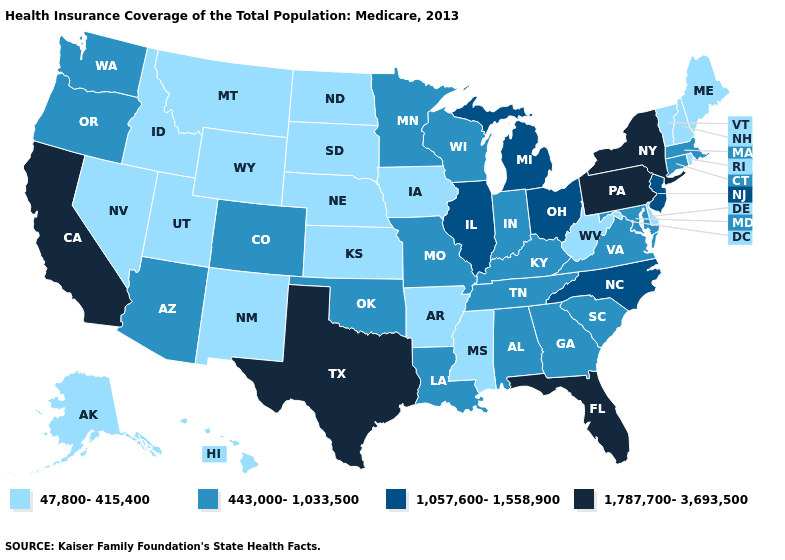Name the states that have a value in the range 443,000-1,033,500?
Answer briefly. Alabama, Arizona, Colorado, Connecticut, Georgia, Indiana, Kentucky, Louisiana, Maryland, Massachusetts, Minnesota, Missouri, Oklahoma, Oregon, South Carolina, Tennessee, Virginia, Washington, Wisconsin. Name the states that have a value in the range 1,057,600-1,558,900?
Concise answer only. Illinois, Michigan, New Jersey, North Carolina, Ohio. Name the states that have a value in the range 1,057,600-1,558,900?
Quick response, please. Illinois, Michigan, New Jersey, North Carolina, Ohio. Is the legend a continuous bar?
Short answer required. No. Among the states that border Nebraska , which have the lowest value?
Concise answer only. Iowa, Kansas, South Dakota, Wyoming. How many symbols are there in the legend?
Keep it brief. 4. Name the states that have a value in the range 1,787,700-3,693,500?
Write a very short answer. California, Florida, New York, Pennsylvania, Texas. Does New York have the lowest value in the USA?
Concise answer only. No. How many symbols are there in the legend?
Give a very brief answer. 4. How many symbols are there in the legend?
Short answer required. 4. Does the map have missing data?
Write a very short answer. No. Name the states that have a value in the range 47,800-415,400?
Write a very short answer. Alaska, Arkansas, Delaware, Hawaii, Idaho, Iowa, Kansas, Maine, Mississippi, Montana, Nebraska, Nevada, New Hampshire, New Mexico, North Dakota, Rhode Island, South Dakota, Utah, Vermont, West Virginia, Wyoming. What is the value of New York?
Keep it brief. 1,787,700-3,693,500. Does Hawaii have a lower value than Alaska?
Write a very short answer. No. Which states have the lowest value in the South?
Concise answer only. Arkansas, Delaware, Mississippi, West Virginia. 